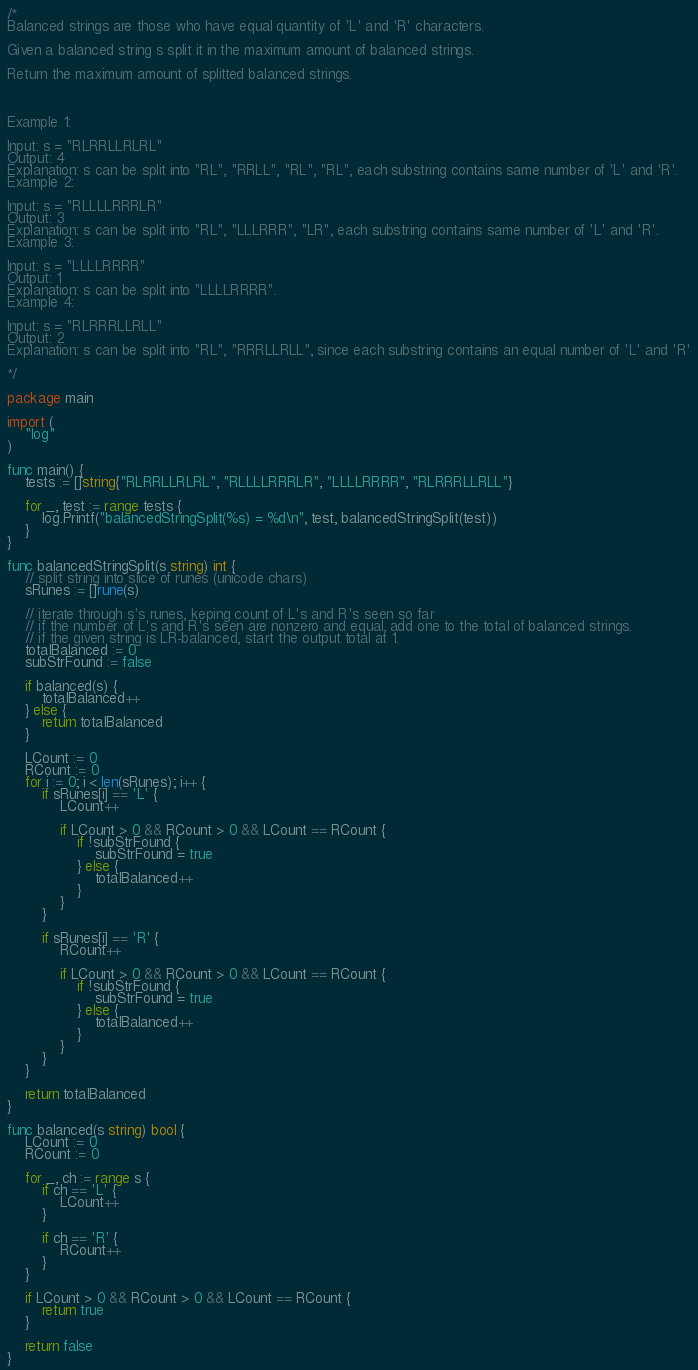<code> <loc_0><loc_0><loc_500><loc_500><_Go_>/*
Balanced strings are those who have equal quantity of 'L' and 'R' characters.

Given a balanced string s split it in the maximum amount of balanced strings.

Return the maximum amount of splitted balanced strings.



Example 1:

Input: s = "RLRRLLRLRL"
Output: 4
Explanation: s can be split into "RL", "RRLL", "RL", "RL", each substring contains same number of 'L' and 'R'.
Example 2:

Input: s = "RLLLLRRRLR"
Output: 3
Explanation: s can be split into "RL", "LLLRRR", "LR", each substring contains same number of 'L' and 'R'.
Example 3:

Input: s = "LLLLRRRR"
Output: 1
Explanation: s can be split into "LLLLRRRR".
Example 4:

Input: s = "RLRRRLLRLL"
Output: 2
Explanation: s can be split into "RL", "RRRLLRLL", since each substring contains an equal number of 'L' and 'R'

*/

package main

import (
	"log"
)

func main() {
	tests := []string{"RLRRLLRLRL", "RLLLLRRRLR", "LLLLRRRR", "RLRRRLLRLL"}

	for _, test := range tests {
		log.Printf("balancedStringSplit(%s) = %d\n", test, balancedStringSplit(test))
	}
}

func balancedStringSplit(s string) int {
	// split string into slice of runes (unicode chars)
	sRunes := []rune(s)

	// iterate through s's runes, keping count of L's and R's seen so far
	// if the number of L's and R's seen are nonzero and equal, add one to the total of balanced strings.
	// if the given string is LR-balanced, start the output total at 1.
	totalBalanced := 0
	subStrFound := false

	if balanced(s) {
		totalBalanced++
	} else {
		return totalBalanced
	}

	LCount := 0
	RCount := 0
	for i := 0; i < len(sRunes); i++ {
		if sRunes[i] == 'L' {
			LCount++

			if LCount > 0 && RCount > 0 && LCount == RCount {
				if !subStrFound {
					subStrFound = true
				} else {
					totalBalanced++
				}
			}
		}

		if sRunes[i] == 'R' {
			RCount++

			if LCount > 0 && RCount > 0 && LCount == RCount {
				if !subStrFound {
					subStrFound = true
				} else {
					totalBalanced++
				}
			}
		}
	}

	return totalBalanced
}

func balanced(s string) bool {
	LCount := 0
	RCount := 0

	for _, ch := range s {
		if ch == 'L' {
			LCount++
		}

		if ch == 'R' {
			RCount++
		}
	}

	if LCount > 0 && RCount > 0 && LCount == RCount {
		return true
	}

	return false
}
</code> 